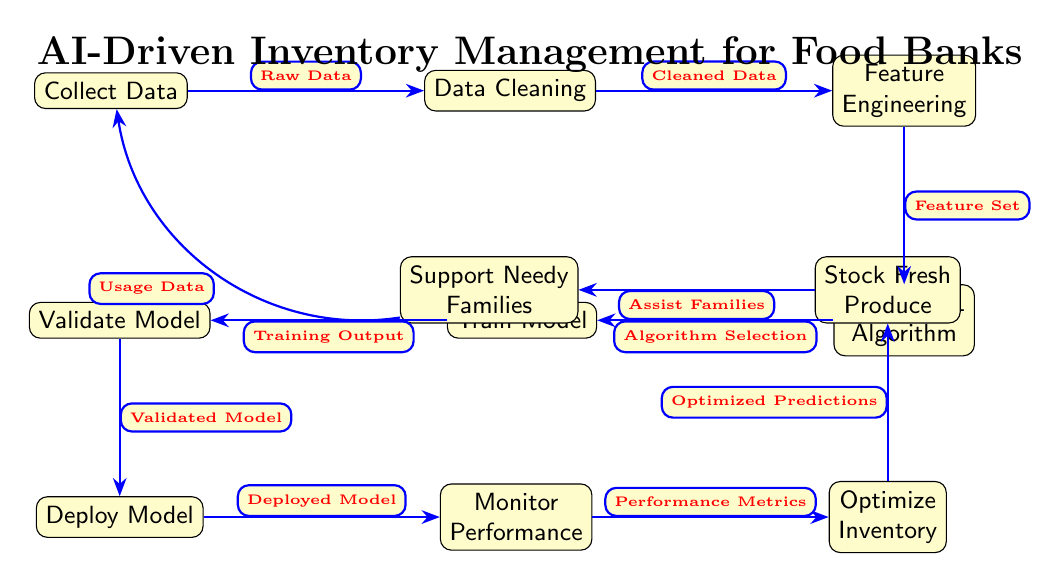What is the first step in the process? The diagram indicates that the first step is "Collect Data," positioned at the top left corner.
Answer: Collect Data How many nodes are there in total? By counting all the labeled nodes in the diagram, there are a total of eleven nodes.
Answer: 11 What does the "Deploy Model" node receive as input? The input to the "Deploy Model" node comes from the "Validated Model" node, which is the step prior in the process.
Answer: Validated Model Which node comes after "Monitor Performance"? Following "Monitor Performance," the next node is "Optimize Inventory," which is located immediately to the right.
Answer: Optimize Inventory What is the final node in the process? The last node in the flowchart is "Support Needy Families," which signifies the ultimate goal of the process.
Answer: Support Needy Families What type of data is represented in the arrow from "Support Needy Families" back to "Collect Data"? The arrow indicates "Usage Data," reflecting the feedback loop aspect of the process.
Answer: Usage Data Which step involves selecting a machine learning algorithm? The diagram shows that algorithm selection is part of the "Choose ML Algorithm" step, which is located below the "Feature Engineering" node.
Answer: Choose ML Algorithm What type of output does the "Train Model" node generate? The output from the "Train Model" node is referred to as the "Training Output," which is directed towards the "Validate Model" node.
Answer: Training Output How does the information flow back to the beginning of the diagram? The flow returns to the "Collect Data" node through the "Usage Data" arrow stemming from the "Support Needy Families" node, indicating a cyclical process.
Answer: Usage Data 